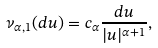<formula> <loc_0><loc_0><loc_500><loc_500>\nu _ { \alpha , 1 } ( d u ) = c _ { \alpha } \frac { d u } { | u | ^ { \alpha + 1 } } ,</formula> 